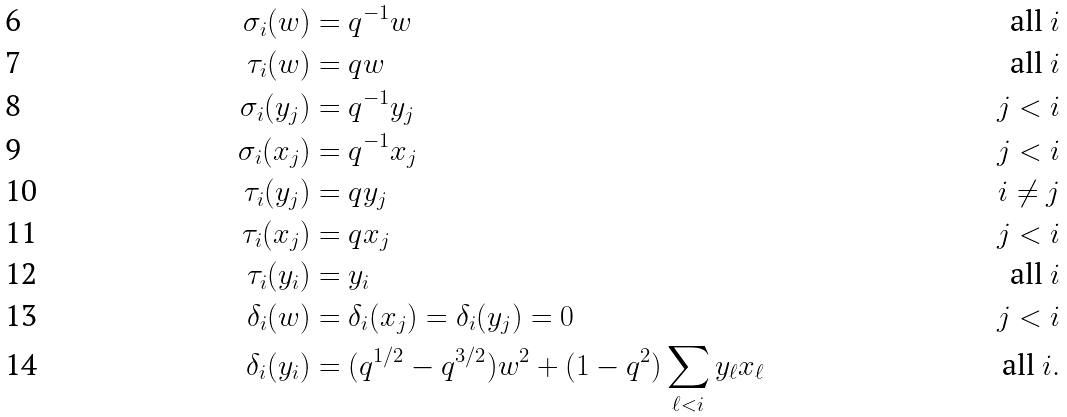<formula> <loc_0><loc_0><loc_500><loc_500>\sigma _ { i } ( w ) & = q ^ { - 1 } w & \text {all } i \\ \tau _ { i } ( w ) & = q w & \text {all } i \\ \sigma _ { i } ( y _ { j } ) & = q ^ { - 1 } y _ { j } & j < i \\ \sigma _ { i } ( x _ { j } ) & = q ^ { - 1 } x _ { j } & j < i \\ \tau _ { i } ( y _ { j } ) & = q y _ { j } & i \ne j \\ \tau _ { i } ( x _ { j } ) & = q x _ { j } & j < i \\ \tau _ { i } ( y _ { i } ) & = y _ { i } & \text {all } i \\ \delta _ { i } ( w ) & = \delta _ { i } ( x _ { j } ) = \delta _ { i } ( y _ { j } ) = 0 & j < i \\ \delta _ { i } ( y _ { i } ) & = ( q ^ { 1 / 2 } - q ^ { 3 / 2 } ) w ^ { 2 } + ( 1 - q ^ { 2 } ) \sum _ { \ell < i } y _ { \ell } x _ { \ell } & \text {all } i .</formula> 